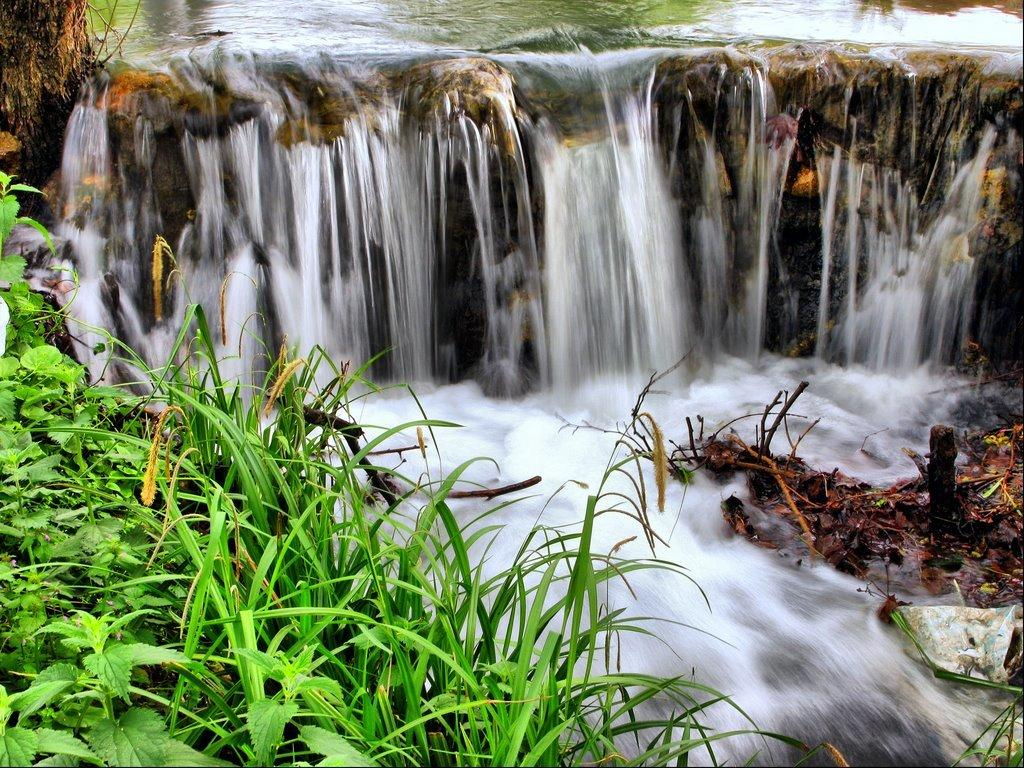What type of vegetation can be seen in the image? There are plants in the image. What color is the grass in the image? The grass in the image is green. What natural feature is present in the image? There is a waterfall in the image. What can be seen in the background of the image? There is water visible in the background of the image. What type of selection process is being used to choose the best cast for the waterfall in the image? There is no indication of a selection process or cast in the image; it simply features a waterfall and plants. 